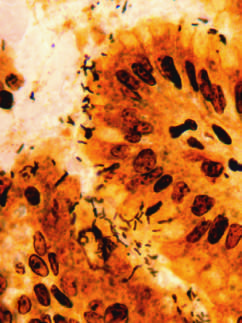what are abundant within surface mucus?
Answer the question using a single word or phrase. Organisms 